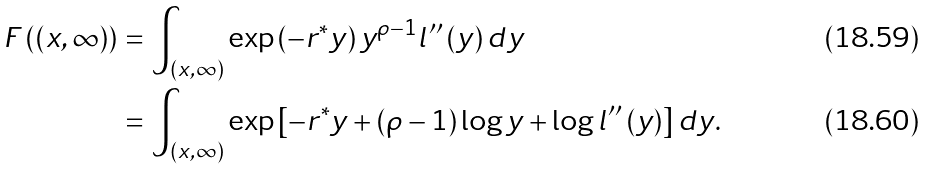Convert formula to latex. <formula><loc_0><loc_0><loc_500><loc_500>F \left ( ( x , \infty ) \right ) & = \int _ { ( x , \infty ) } \exp \left ( - r ^ { \ast } y \right ) y ^ { \rho - 1 } l ^ { \prime \prime } \left ( y \right ) d y \\ & = \int _ { ( x , \infty ) } \exp \left [ - r ^ { \ast } y + \left ( \rho - 1 \right ) \log y + \log l ^ { \prime \prime } \left ( y \right ) \right ] d y .</formula> 